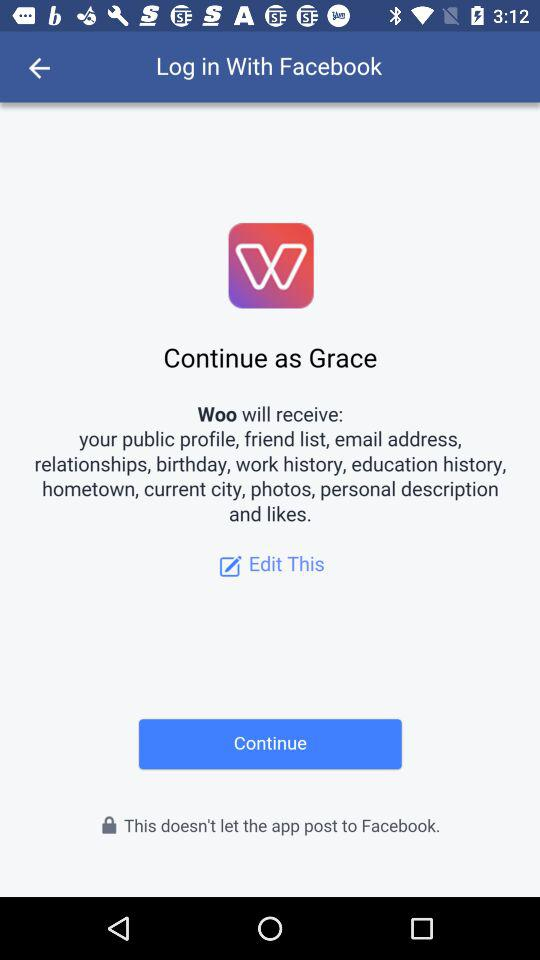What application is asking for permission? The application asking for permission is "Woo". 